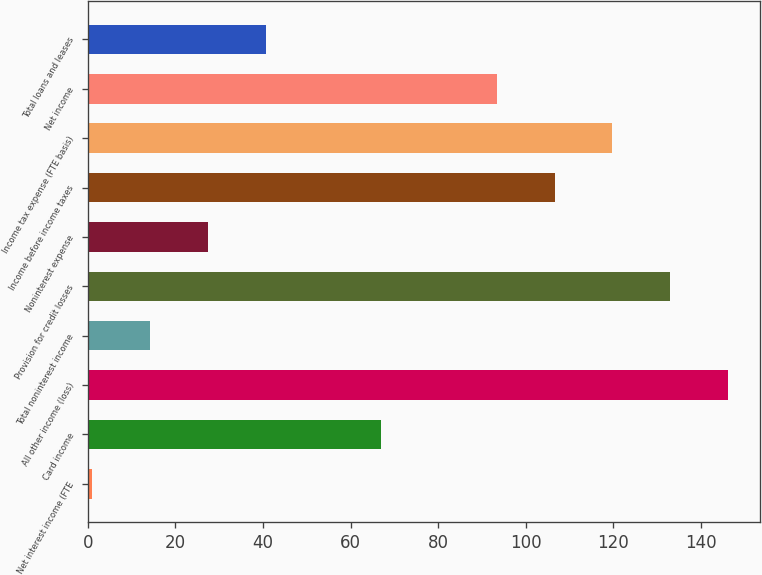Convert chart. <chart><loc_0><loc_0><loc_500><loc_500><bar_chart><fcel>Net interest income (FTE<fcel>Card income<fcel>All other income (loss)<fcel>Total noninterest income<fcel>Provision for credit losses<fcel>Noninterest expense<fcel>Income before income taxes<fcel>Income tax expense (FTE basis)<fcel>Net income<fcel>Total loans and leases<nl><fcel>1<fcel>67<fcel>146.2<fcel>14.2<fcel>133<fcel>27.4<fcel>106.6<fcel>119.8<fcel>93.4<fcel>40.6<nl></chart> 